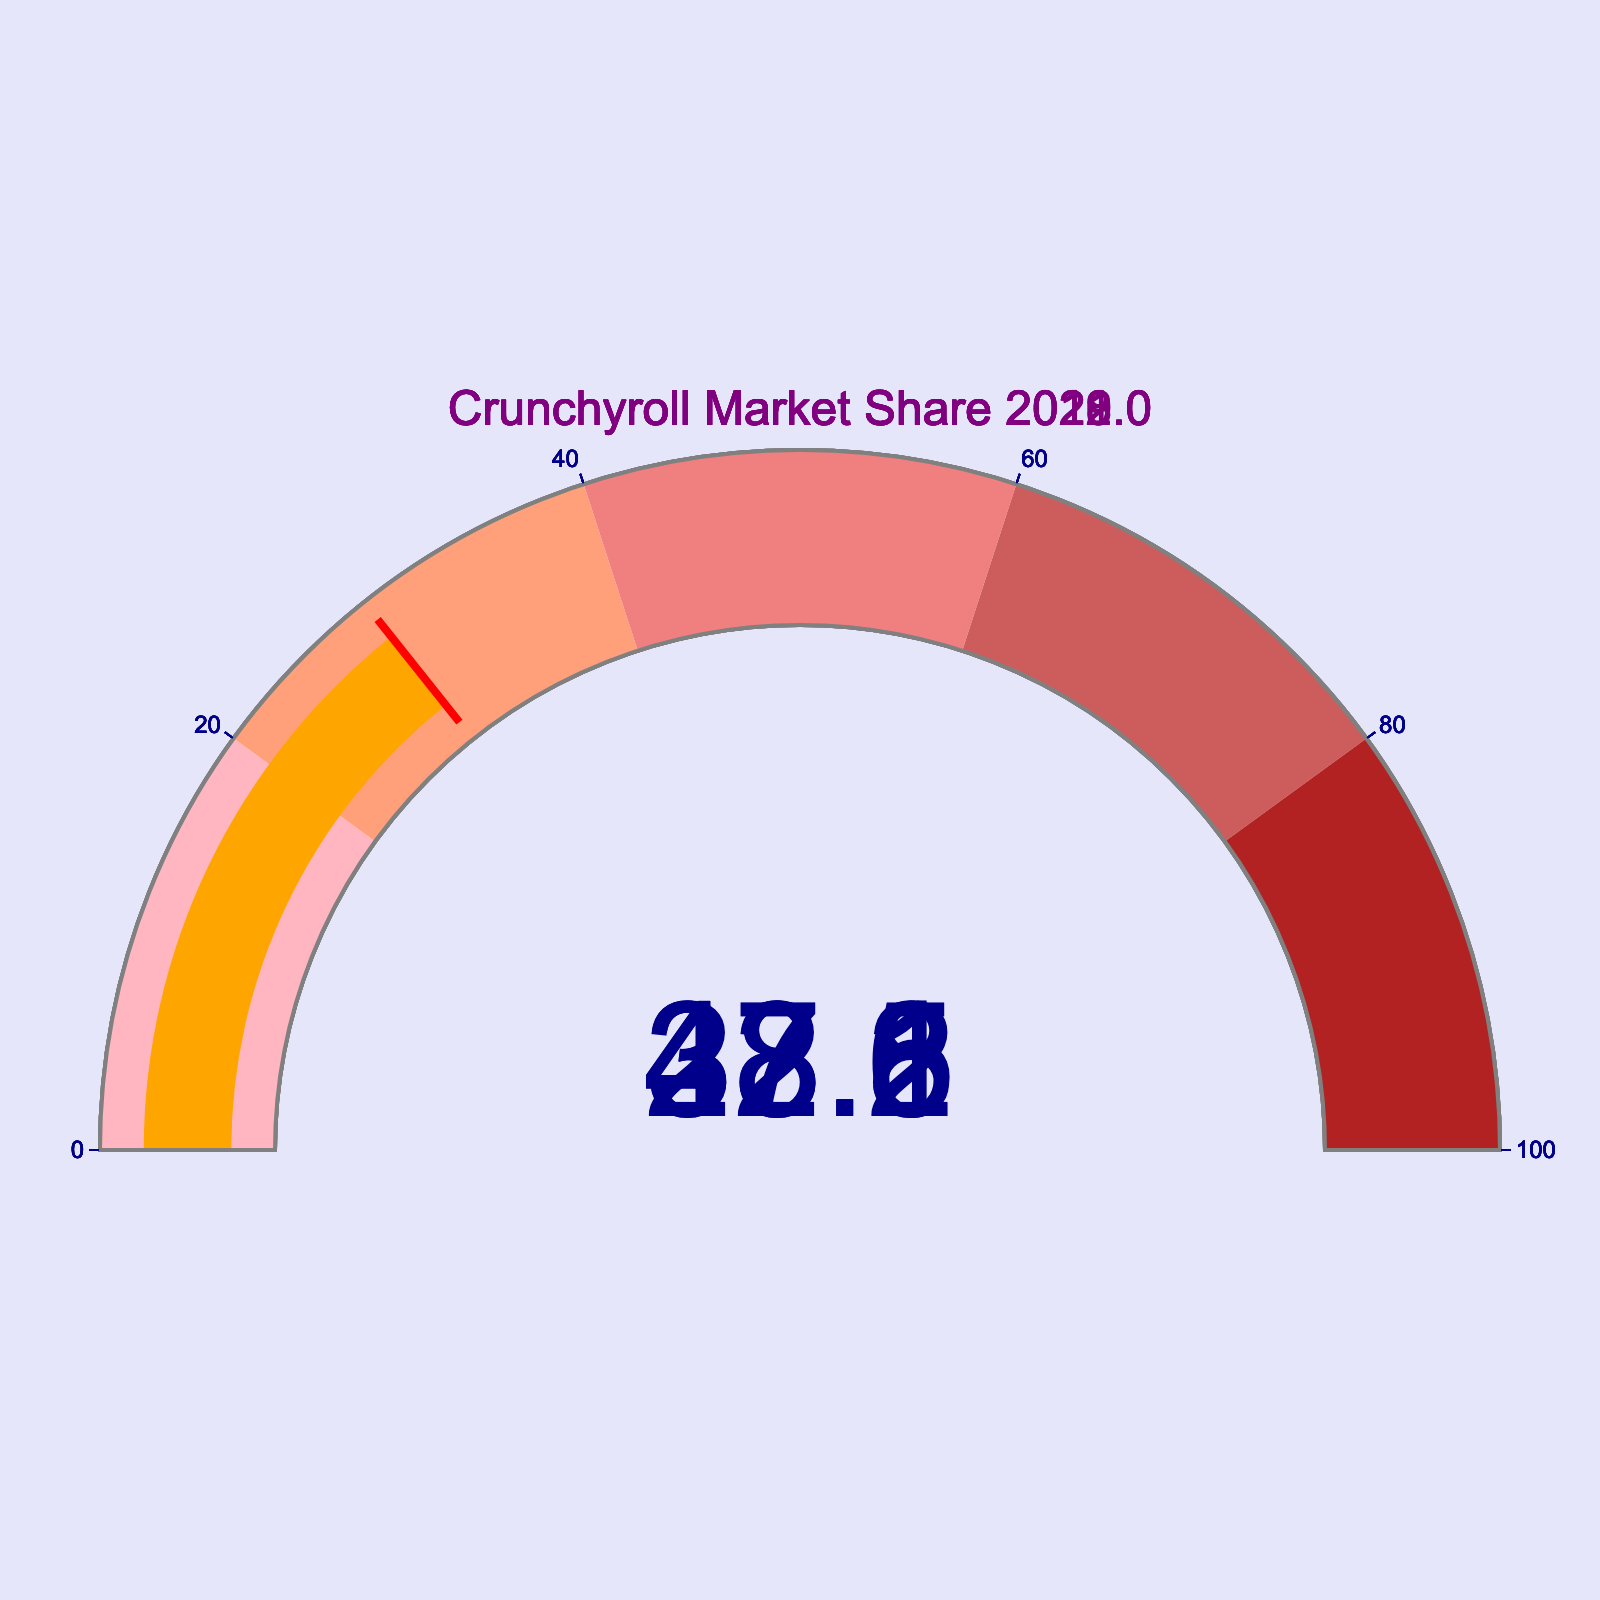What's the market share of Crunchyroll in 2022? The gauge for the year 2022 shows a market share of 48.5%, as indicated by the needle position and the number displayed.
Answer: 48.5% How much did Crunchyroll's market share increase from 2018 to 2022? In 2018, the market share was 28.6%. By 2022, it increased to 48.5%. The increase is 48.5% - 28.6% = 19.9%.
Answer: 19.9% Which year shows a market share of less than 30%? Looking at the gauges, 2018 shows a market share of 28.6%, which is less than 30%.
Answer: 2018 What is the average market share of Crunchyroll from 2018 to 2022? The market shares for the years 2018 to 2022 are 28.6%, 32.1%, 37.8%, 43.2%, and 48.5%. Their average is (28.6 + 32.1 + 37.8 + 43.2 + 48.5)/5 = 38.04%.
Answer: 38.04% Which year has the second highest market share? First, identify the highest market share (48.5% in 2022). The second highest is 43.2% in 2021.
Answer: 2021 By how much did Crunchyroll's market share grow from 2019 to 2020? For 2019, the market share was 32.1%. For 2020, it increased to 37.8%. The growth is 37.8% - 32.1% = 5.7%.
Answer: 5.7% Between which consecutive years did Crunchyroll see the largest increase in market share? Calculate the increases for each consecutive year: 2018-2019 = 32.1% - 28.6% = 3.5%, 2019-2020 = 37.8% - 32.1% = 5.7%, 2020-2021 = 43.2% - 37.8% = 5.4%, 2021-2022 = 48.5% - 43.2% = 5.3%. The largest increase is from 2019 to 2020.
Answer: 2019 to 2020 What color does the gauge display for the 2022 market share segment? The gauge uses an orange bar to display the market share. Since 48.5% is within the range of 40-60%, the corresponding background step color is lightcoral.
Answer: lightcoral What was the market share of Crunchyroll in the lowest recorded year between 2018 to 2022? Reviewing all the gauge readings, the lowest market share recorded between 2018 to 2022 is 28.6% in 2018.
Answer: 28.6% Is there any year where Crunchyroll's market share was in the range of 20% to 40%? Checking the gauges, in 2018 (28.6%) and 2019 (32.1%), the market share is within the range of 20% to 40%.
Answer: Yes 